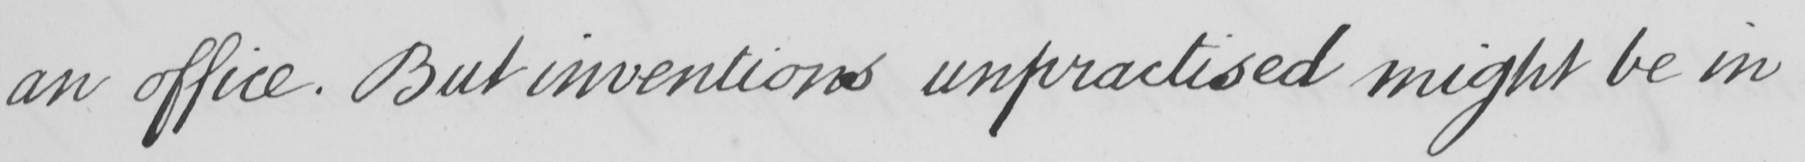What does this handwritten line say? an office . But inventions unpractised might be in 